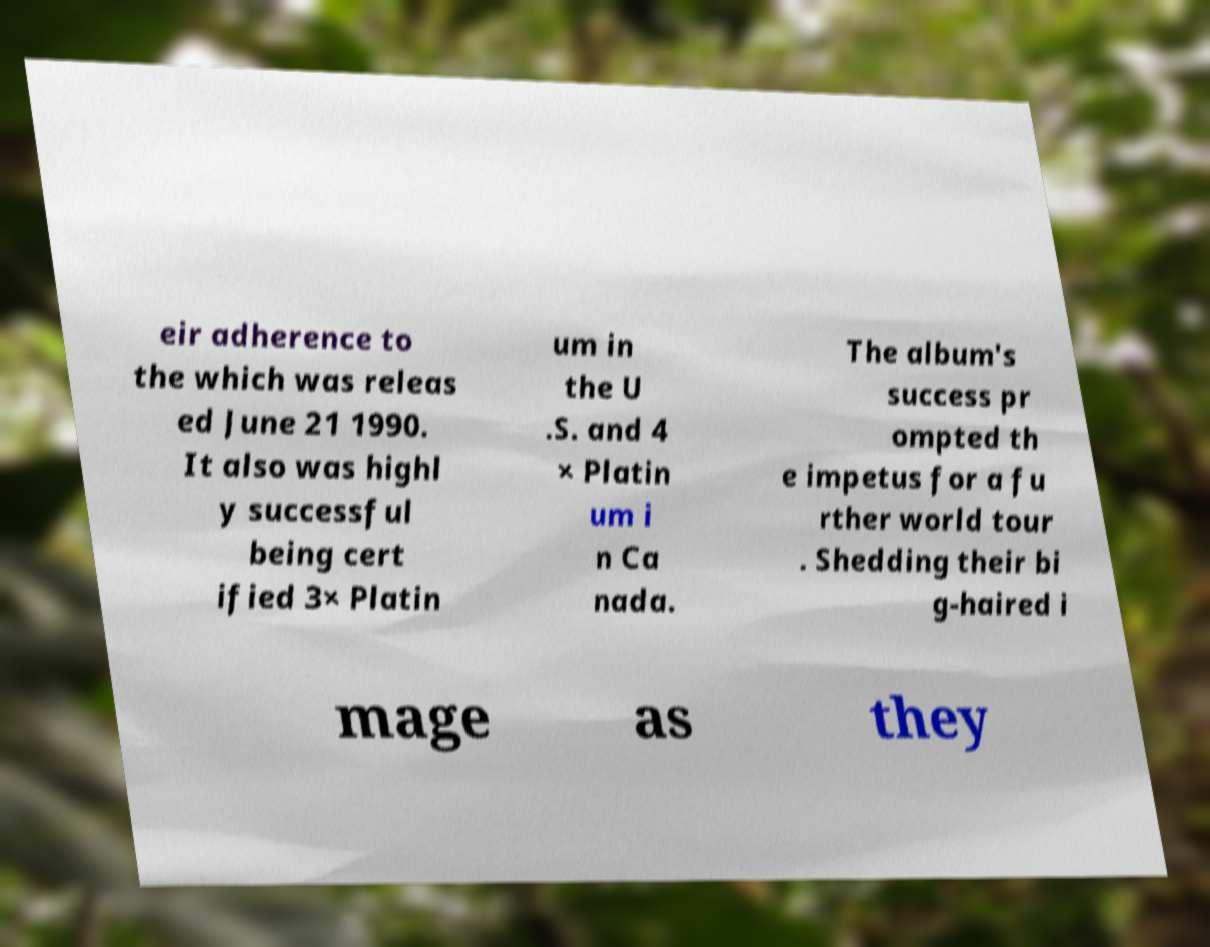There's text embedded in this image that I need extracted. Can you transcribe it verbatim? eir adherence to the which was releas ed June 21 1990. It also was highl y successful being cert ified 3× Platin um in the U .S. and 4 × Platin um i n Ca nada. The album's success pr ompted th e impetus for a fu rther world tour . Shedding their bi g-haired i mage as they 